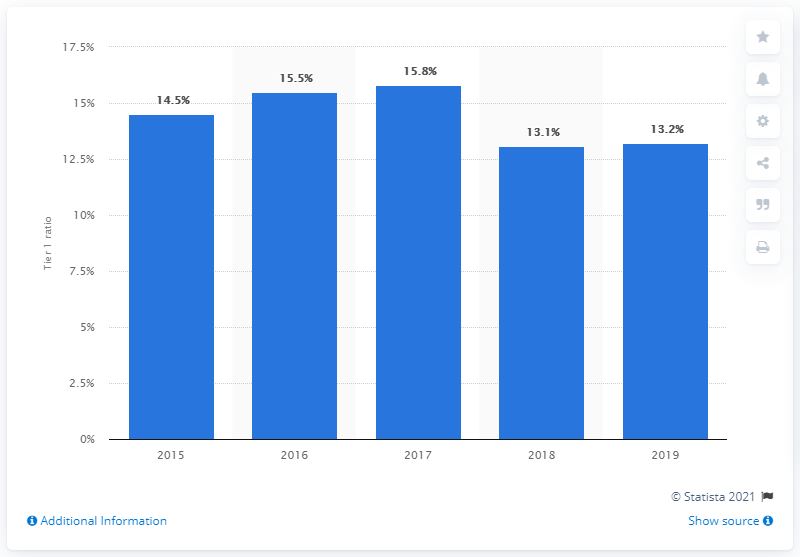What was the tier 1 ratio of Crdit Agricole in 2019?
 13.2 